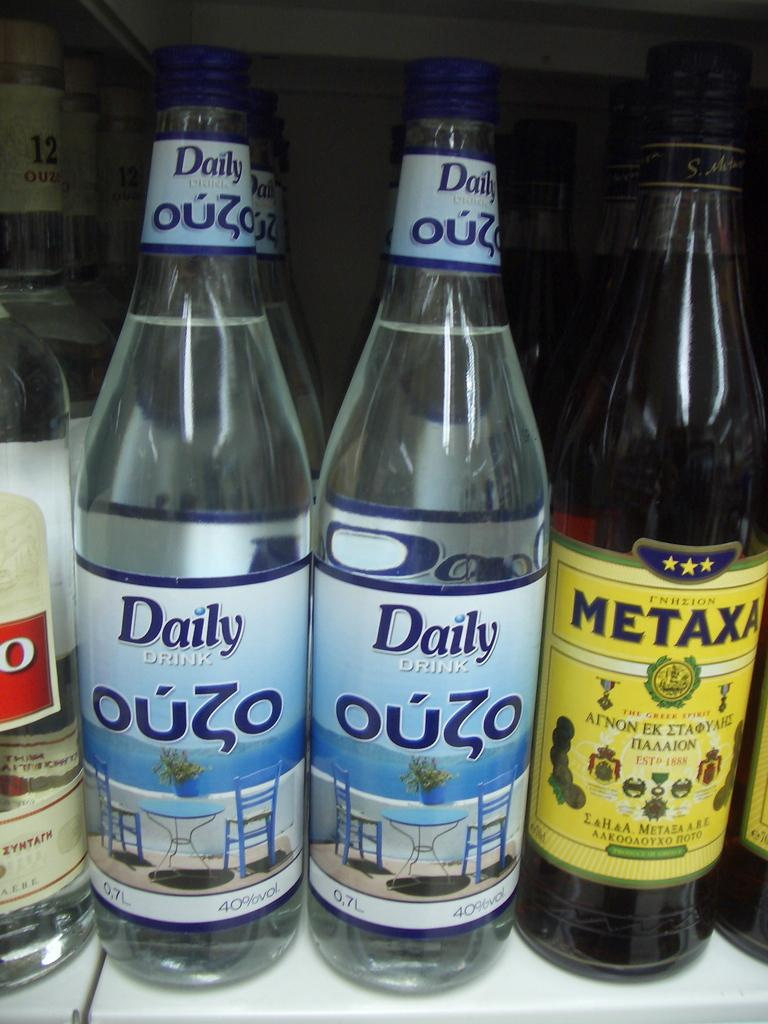Provide a one-sentence caption for the provided image. The shelf contains bottles of liquor including Daily Ouzo and Metaxa. 